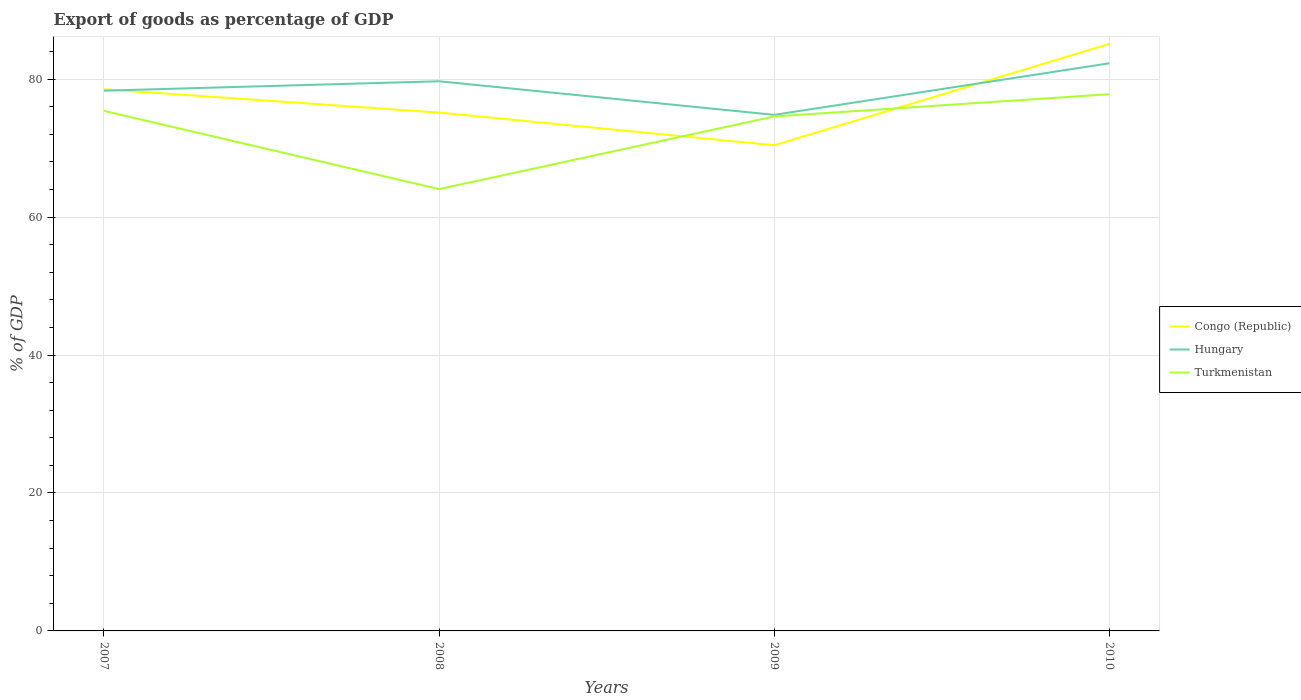Does the line corresponding to Hungary intersect with the line corresponding to Turkmenistan?
Provide a succinct answer. No. Is the number of lines equal to the number of legend labels?
Your answer should be very brief. Yes. Across all years, what is the maximum export of goods as percentage of GDP in Hungary?
Provide a succinct answer. 74.82. What is the total export of goods as percentage of GDP in Hungary in the graph?
Give a very brief answer. 4.87. What is the difference between the highest and the second highest export of goods as percentage of GDP in Hungary?
Make the answer very short. 7.48. How many lines are there?
Your answer should be very brief. 3. Are the values on the major ticks of Y-axis written in scientific E-notation?
Offer a very short reply. No. Does the graph contain grids?
Give a very brief answer. Yes. What is the title of the graph?
Your response must be concise. Export of goods as percentage of GDP. What is the label or title of the X-axis?
Your response must be concise. Years. What is the label or title of the Y-axis?
Offer a very short reply. % of GDP. What is the % of GDP in Congo (Republic) in 2007?
Keep it short and to the point. 78.53. What is the % of GDP in Hungary in 2007?
Offer a terse response. 78.33. What is the % of GDP of Turkmenistan in 2007?
Give a very brief answer. 75.39. What is the % of GDP of Congo (Republic) in 2008?
Your response must be concise. 75.15. What is the % of GDP in Hungary in 2008?
Make the answer very short. 79.69. What is the % of GDP of Turkmenistan in 2008?
Give a very brief answer. 64.06. What is the % of GDP of Congo (Republic) in 2009?
Keep it short and to the point. 70.42. What is the % of GDP of Hungary in 2009?
Ensure brevity in your answer.  74.82. What is the % of GDP in Turkmenistan in 2009?
Your answer should be compact. 74.6. What is the % of GDP in Congo (Republic) in 2010?
Make the answer very short. 85.12. What is the % of GDP of Hungary in 2010?
Provide a succinct answer. 82.3. What is the % of GDP in Turkmenistan in 2010?
Keep it short and to the point. 77.81. Across all years, what is the maximum % of GDP in Congo (Republic)?
Provide a succinct answer. 85.12. Across all years, what is the maximum % of GDP of Hungary?
Offer a very short reply. 82.3. Across all years, what is the maximum % of GDP in Turkmenistan?
Ensure brevity in your answer.  77.81. Across all years, what is the minimum % of GDP in Congo (Republic)?
Make the answer very short. 70.42. Across all years, what is the minimum % of GDP in Hungary?
Offer a terse response. 74.82. Across all years, what is the minimum % of GDP of Turkmenistan?
Keep it short and to the point. 64.06. What is the total % of GDP in Congo (Republic) in the graph?
Provide a succinct answer. 309.22. What is the total % of GDP in Hungary in the graph?
Your answer should be very brief. 315.14. What is the total % of GDP of Turkmenistan in the graph?
Your answer should be compact. 291.86. What is the difference between the % of GDP in Congo (Republic) in 2007 and that in 2008?
Provide a short and direct response. 3.38. What is the difference between the % of GDP in Hungary in 2007 and that in 2008?
Your response must be concise. -1.36. What is the difference between the % of GDP in Turkmenistan in 2007 and that in 2008?
Give a very brief answer. 11.34. What is the difference between the % of GDP of Congo (Republic) in 2007 and that in 2009?
Ensure brevity in your answer.  8.11. What is the difference between the % of GDP of Hungary in 2007 and that in 2009?
Offer a terse response. 3.51. What is the difference between the % of GDP of Turkmenistan in 2007 and that in 2009?
Give a very brief answer. 0.8. What is the difference between the % of GDP in Congo (Republic) in 2007 and that in 2010?
Give a very brief answer. -6.59. What is the difference between the % of GDP of Hungary in 2007 and that in 2010?
Make the answer very short. -3.97. What is the difference between the % of GDP in Turkmenistan in 2007 and that in 2010?
Offer a very short reply. -2.42. What is the difference between the % of GDP of Congo (Republic) in 2008 and that in 2009?
Ensure brevity in your answer.  4.73. What is the difference between the % of GDP in Hungary in 2008 and that in 2009?
Your response must be concise. 4.87. What is the difference between the % of GDP in Turkmenistan in 2008 and that in 2009?
Your response must be concise. -10.54. What is the difference between the % of GDP of Congo (Republic) in 2008 and that in 2010?
Provide a succinct answer. -9.97. What is the difference between the % of GDP of Hungary in 2008 and that in 2010?
Your answer should be very brief. -2.61. What is the difference between the % of GDP in Turkmenistan in 2008 and that in 2010?
Your answer should be very brief. -13.76. What is the difference between the % of GDP in Congo (Republic) in 2009 and that in 2010?
Offer a terse response. -14.7. What is the difference between the % of GDP of Hungary in 2009 and that in 2010?
Your answer should be very brief. -7.48. What is the difference between the % of GDP of Turkmenistan in 2009 and that in 2010?
Provide a short and direct response. -3.22. What is the difference between the % of GDP of Congo (Republic) in 2007 and the % of GDP of Hungary in 2008?
Offer a very short reply. -1.16. What is the difference between the % of GDP of Congo (Republic) in 2007 and the % of GDP of Turkmenistan in 2008?
Keep it short and to the point. 14.47. What is the difference between the % of GDP of Hungary in 2007 and the % of GDP of Turkmenistan in 2008?
Provide a short and direct response. 14.27. What is the difference between the % of GDP of Congo (Republic) in 2007 and the % of GDP of Hungary in 2009?
Your response must be concise. 3.71. What is the difference between the % of GDP in Congo (Republic) in 2007 and the % of GDP in Turkmenistan in 2009?
Your response must be concise. 3.93. What is the difference between the % of GDP of Hungary in 2007 and the % of GDP of Turkmenistan in 2009?
Give a very brief answer. 3.73. What is the difference between the % of GDP of Congo (Republic) in 2007 and the % of GDP of Hungary in 2010?
Give a very brief answer. -3.77. What is the difference between the % of GDP in Congo (Republic) in 2007 and the % of GDP in Turkmenistan in 2010?
Your answer should be very brief. 0.71. What is the difference between the % of GDP of Hungary in 2007 and the % of GDP of Turkmenistan in 2010?
Offer a very short reply. 0.51. What is the difference between the % of GDP in Congo (Republic) in 2008 and the % of GDP in Hungary in 2009?
Make the answer very short. 0.33. What is the difference between the % of GDP in Congo (Republic) in 2008 and the % of GDP in Turkmenistan in 2009?
Ensure brevity in your answer.  0.56. What is the difference between the % of GDP in Hungary in 2008 and the % of GDP in Turkmenistan in 2009?
Give a very brief answer. 5.1. What is the difference between the % of GDP in Congo (Republic) in 2008 and the % of GDP in Hungary in 2010?
Provide a succinct answer. -7.15. What is the difference between the % of GDP in Congo (Republic) in 2008 and the % of GDP in Turkmenistan in 2010?
Your answer should be very brief. -2.66. What is the difference between the % of GDP of Hungary in 2008 and the % of GDP of Turkmenistan in 2010?
Give a very brief answer. 1.88. What is the difference between the % of GDP of Congo (Republic) in 2009 and the % of GDP of Hungary in 2010?
Give a very brief answer. -11.88. What is the difference between the % of GDP of Congo (Republic) in 2009 and the % of GDP of Turkmenistan in 2010?
Keep it short and to the point. -7.4. What is the difference between the % of GDP in Hungary in 2009 and the % of GDP in Turkmenistan in 2010?
Make the answer very short. -2.99. What is the average % of GDP of Congo (Republic) per year?
Your answer should be very brief. 77.3. What is the average % of GDP of Hungary per year?
Offer a terse response. 78.79. What is the average % of GDP in Turkmenistan per year?
Provide a short and direct response. 72.97. In the year 2007, what is the difference between the % of GDP of Congo (Republic) and % of GDP of Hungary?
Offer a very short reply. 0.2. In the year 2007, what is the difference between the % of GDP of Congo (Republic) and % of GDP of Turkmenistan?
Offer a terse response. 3.14. In the year 2007, what is the difference between the % of GDP in Hungary and % of GDP in Turkmenistan?
Offer a very short reply. 2.93. In the year 2008, what is the difference between the % of GDP in Congo (Republic) and % of GDP in Hungary?
Offer a terse response. -4.54. In the year 2008, what is the difference between the % of GDP in Congo (Republic) and % of GDP in Turkmenistan?
Provide a succinct answer. 11.09. In the year 2008, what is the difference between the % of GDP in Hungary and % of GDP in Turkmenistan?
Ensure brevity in your answer.  15.63. In the year 2009, what is the difference between the % of GDP in Congo (Republic) and % of GDP in Hungary?
Make the answer very short. -4.4. In the year 2009, what is the difference between the % of GDP in Congo (Republic) and % of GDP in Turkmenistan?
Make the answer very short. -4.18. In the year 2009, what is the difference between the % of GDP in Hungary and % of GDP in Turkmenistan?
Ensure brevity in your answer.  0.23. In the year 2010, what is the difference between the % of GDP in Congo (Republic) and % of GDP in Hungary?
Provide a short and direct response. 2.82. In the year 2010, what is the difference between the % of GDP of Congo (Republic) and % of GDP of Turkmenistan?
Ensure brevity in your answer.  7.3. In the year 2010, what is the difference between the % of GDP of Hungary and % of GDP of Turkmenistan?
Keep it short and to the point. 4.49. What is the ratio of the % of GDP in Congo (Republic) in 2007 to that in 2008?
Make the answer very short. 1.04. What is the ratio of the % of GDP of Hungary in 2007 to that in 2008?
Ensure brevity in your answer.  0.98. What is the ratio of the % of GDP in Turkmenistan in 2007 to that in 2008?
Provide a succinct answer. 1.18. What is the ratio of the % of GDP of Congo (Republic) in 2007 to that in 2009?
Provide a short and direct response. 1.12. What is the ratio of the % of GDP in Hungary in 2007 to that in 2009?
Give a very brief answer. 1.05. What is the ratio of the % of GDP in Turkmenistan in 2007 to that in 2009?
Provide a succinct answer. 1.01. What is the ratio of the % of GDP of Congo (Republic) in 2007 to that in 2010?
Your answer should be compact. 0.92. What is the ratio of the % of GDP of Hungary in 2007 to that in 2010?
Make the answer very short. 0.95. What is the ratio of the % of GDP in Turkmenistan in 2007 to that in 2010?
Your answer should be very brief. 0.97. What is the ratio of the % of GDP in Congo (Republic) in 2008 to that in 2009?
Your response must be concise. 1.07. What is the ratio of the % of GDP of Hungary in 2008 to that in 2009?
Ensure brevity in your answer.  1.07. What is the ratio of the % of GDP of Turkmenistan in 2008 to that in 2009?
Offer a very short reply. 0.86. What is the ratio of the % of GDP of Congo (Republic) in 2008 to that in 2010?
Keep it short and to the point. 0.88. What is the ratio of the % of GDP of Hungary in 2008 to that in 2010?
Provide a short and direct response. 0.97. What is the ratio of the % of GDP in Turkmenistan in 2008 to that in 2010?
Ensure brevity in your answer.  0.82. What is the ratio of the % of GDP in Congo (Republic) in 2009 to that in 2010?
Keep it short and to the point. 0.83. What is the ratio of the % of GDP in Turkmenistan in 2009 to that in 2010?
Your answer should be very brief. 0.96. What is the difference between the highest and the second highest % of GDP in Congo (Republic)?
Provide a succinct answer. 6.59. What is the difference between the highest and the second highest % of GDP of Hungary?
Offer a very short reply. 2.61. What is the difference between the highest and the second highest % of GDP of Turkmenistan?
Keep it short and to the point. 2.42. What is the difference between the highest and the lowest % of GDP of Congo (Republic)?
Offer a terse response. 14.7. What is the difference between the highest and the lowest % of GDP of Hungary?
Offer a very short reply. 7.48. What is the difference between the highest and the lowest % of GDP of Turkmenistan?
Keep it short and to the point. 13.76. 